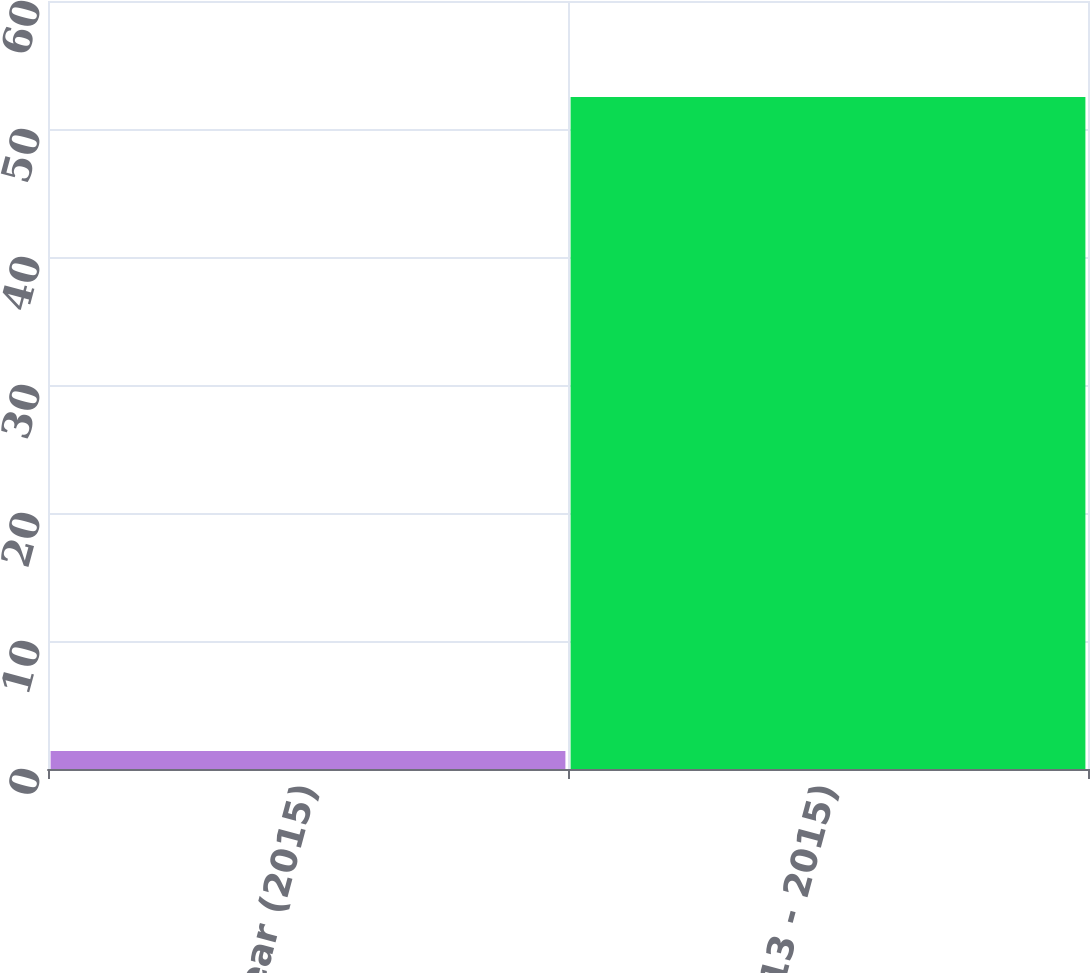Convert chart to OTSL. <chart><loc_0><loc_0><loc_500><loc_500><bar_chart><fcel>1 Year (2015)<fcel>3 Year (2013 - 2015)<nl><fcel>1.4<fcel>52.5<nl></chart> 